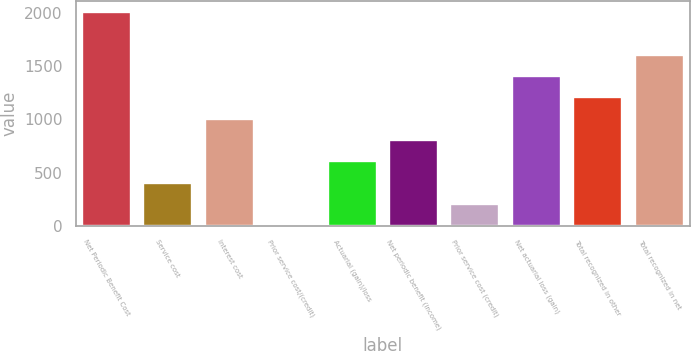Convert chart to OTSL. <chart><loc_0><loc_0><loc_500><loc_500><bar_chart><fcel>Net Periodic Benefit Cost<fcel>Service cost<fcel>Interest cost<fcel>Prior service cost/(credit)<fcel>Actuarial (gain)/loss<fcel>Net periodic benefit (income)<fcel>Prior service cost (credit)<fcel>Net actuarial loss (gain)<fcel>Total recognized in other<fcel>Total recognized in net<nl><fcel>2012<fcel>403.44<fcel>1006.65<fcel>1.3<fcel>604.51<fcel>805.58<fcel>202.37<fcel>1408.79<fcel>1207.72<fcel>1609.86<nl></chart> 